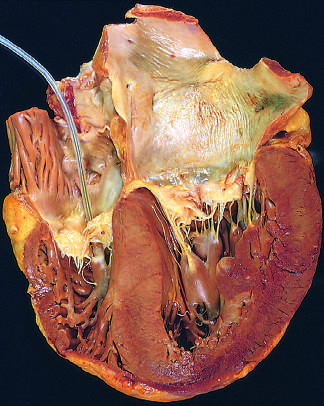re the extensive subcutaneous fibrosis shown on the right in this four-chamber view of the heart?
Answer the question using a single word or phrase. No 